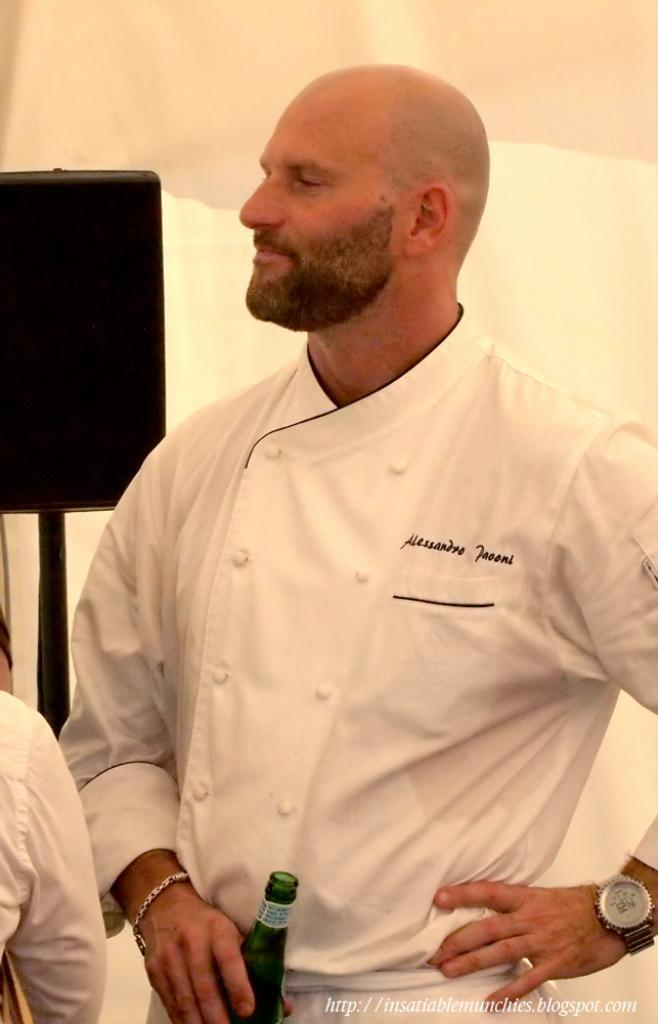<image>
Provide a brief description of the given image. A chef named Alessandro is holding a drink in a green bottle. 